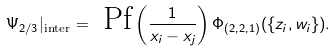Convert formula to latex. <formula><loc_0><loc_0><loc_500><loc_500>\Psi _ { 2 / 3 } | _ { \text {inter} } = \text { Pf} \left ( \frac { 1 } { x _ { i } - x _ { j } } \right ) \Phi _ { ( 2 , 2 , 1 ) } ( \{ z _ { i } , w _ { i } \} ) .</formula> 